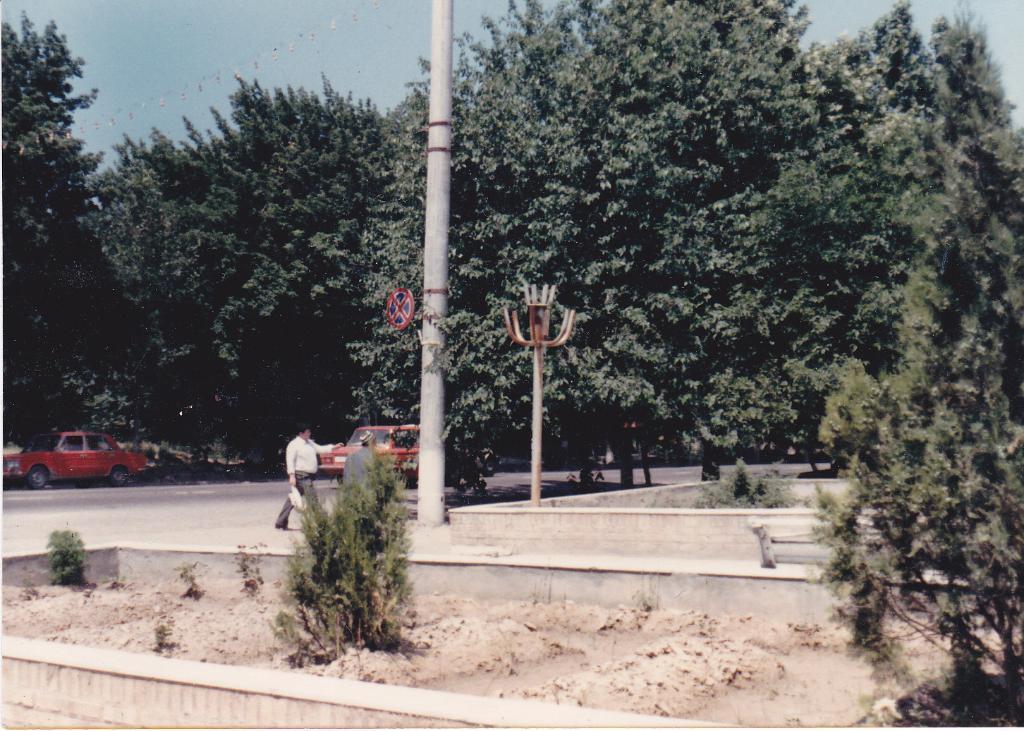Describe this image in one or two sentences. In this image there are some cars on the road beside them there are some trees, also there is a man walking beside the pole. 